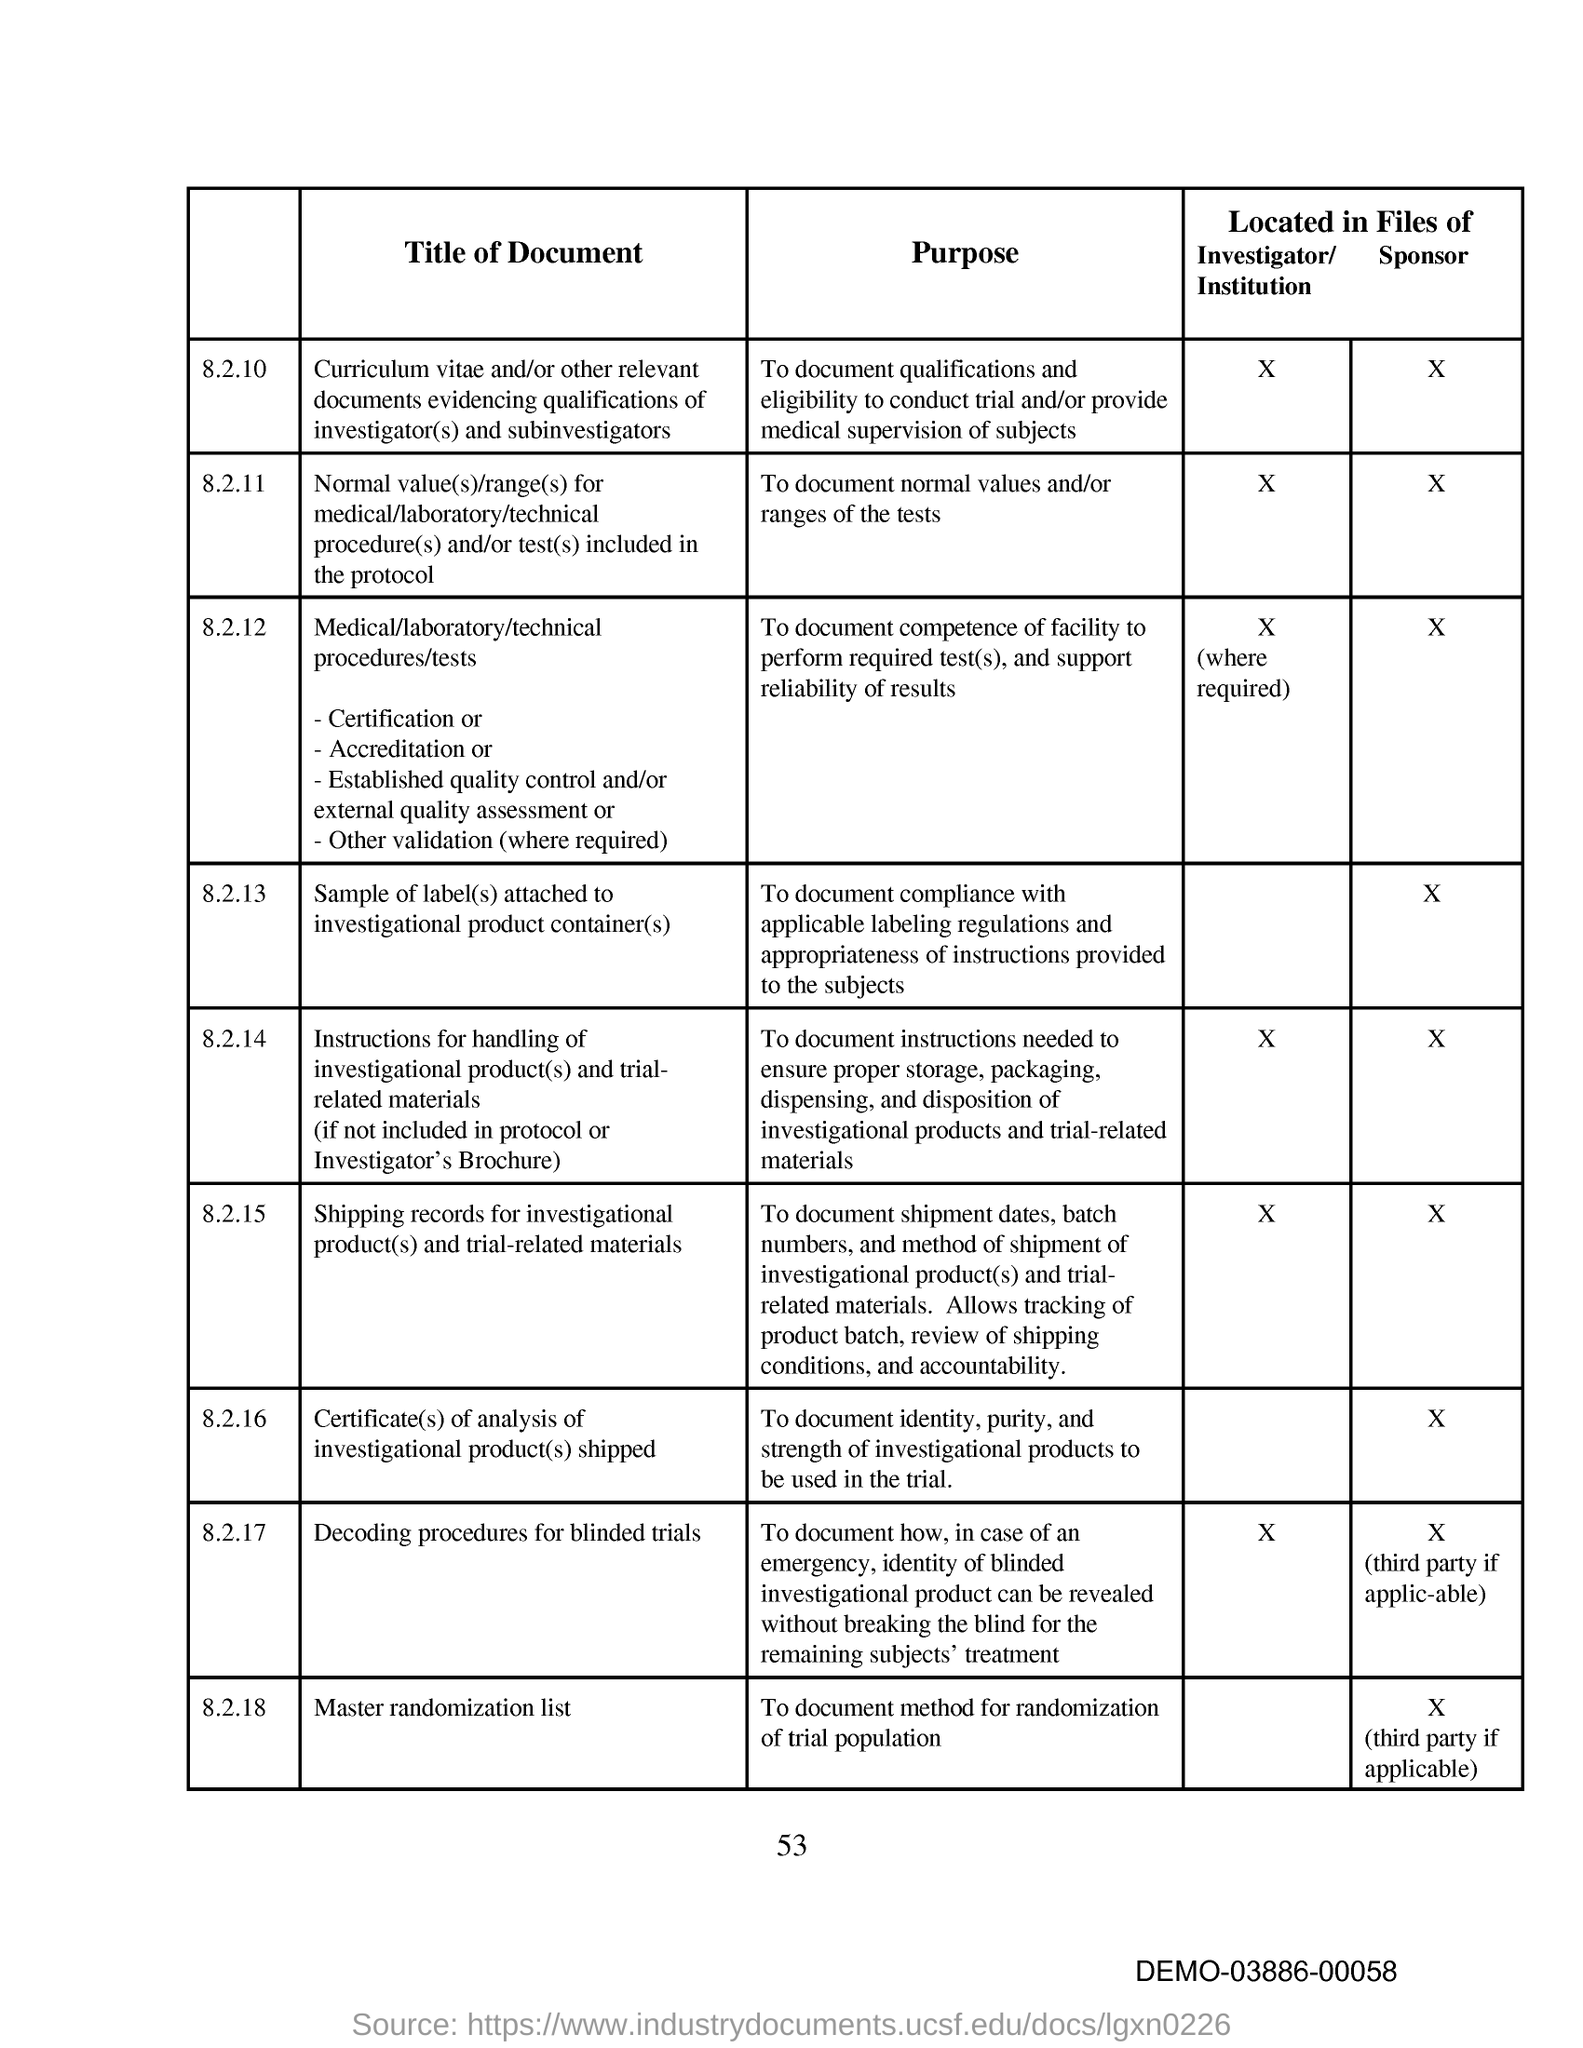Highlight a few significant elements in this photo. The purpose of document under 8.2.11 is to provide a record of the normal values and/or ranges of the tests. 